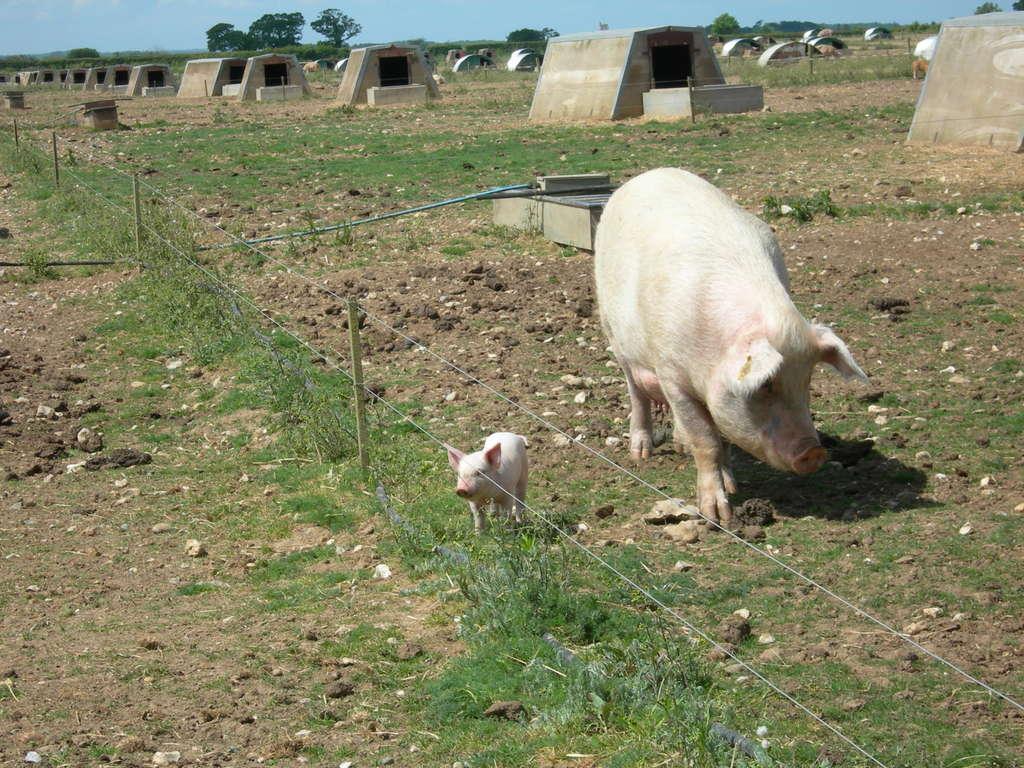Describe this image in one or two sentences. In this image I can see two pigs in white color. Background I can see trees and grass in green color and sky in blue color. 